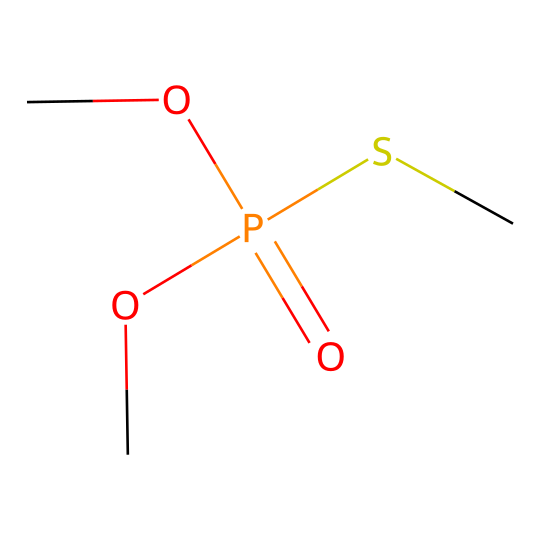What is the main functional group in this chemical? The chemical structure contains a phosphorus atom bonded to an oxygen atom, which suggests the presence of a phosphate functional group. The central phosphorus atom is bonded to oxygen, indicating it is part of a phosphoryl group, characterizing organophosphates.
Answer: phosphate How many carbon atoms are present in the chemical? By examining the SMILES representation, there are two carbon atoms indicated in the structure (the two 'C's in COP(=O)(OC)SC). Each 'C' represents a carbon atom connected to other atoms.
Answer: 2 What type of bond connects phosphorus to oxygen in this structure? In this chemical, the phosphorus atom forms a double bond with one oxygen atom and single bonds with others. The presence of the '=' sign indicates a double bond specifically with the oxygen (upon analysis of the SMILES).
Answer: double bond What is the total number of oxygen atoms in this compound? The SMILES representation shows one oxygen in the double bond and two attached directly to the phosphorus, giving a total of three oxygen atoms. Careful counting based on the structure leads to this conclusion.
Answer: 3 How does the sulfur atom influence the properties of this organophosphate? The presence of the sulfur atom (S) in the structure suggests potential thiol characteristics, which can affect the chemical's reactivity and its biological activity, particularly in terms of toxicity and stability in agricultural applications.
Answer: reactivity Which agricultural application could involve this compound? This compound, being an organophosphate, is likely used as a pesticide in Eastern European agriculture, targeting pests due to its toxic properties towards insects. The common use of organophosphates in pest control is well-established.
Answer: pesticide 